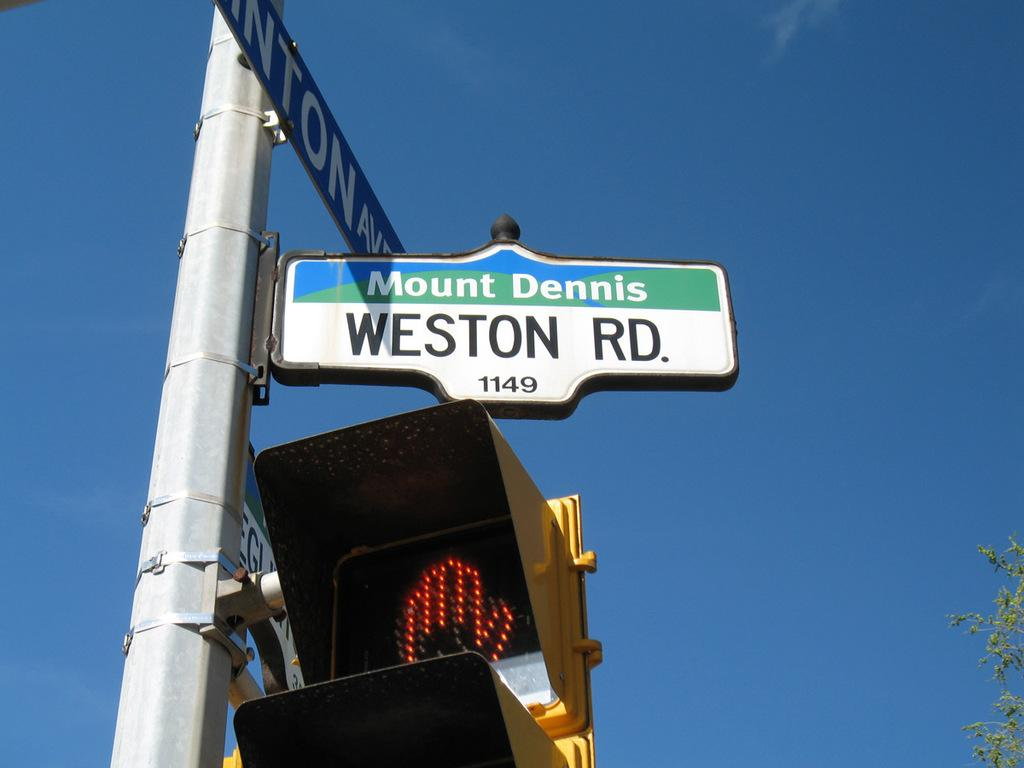Provide a one-sentence caption for the provided image. A street sign saying Mount Dennis Weston Road stands above a traffic light. 